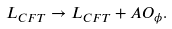<formula> <loc_0><loc_0><loc_500><loc_500>L _ { C F T } \to L _ { C F T } + A O _ { \phi } .</formula> 